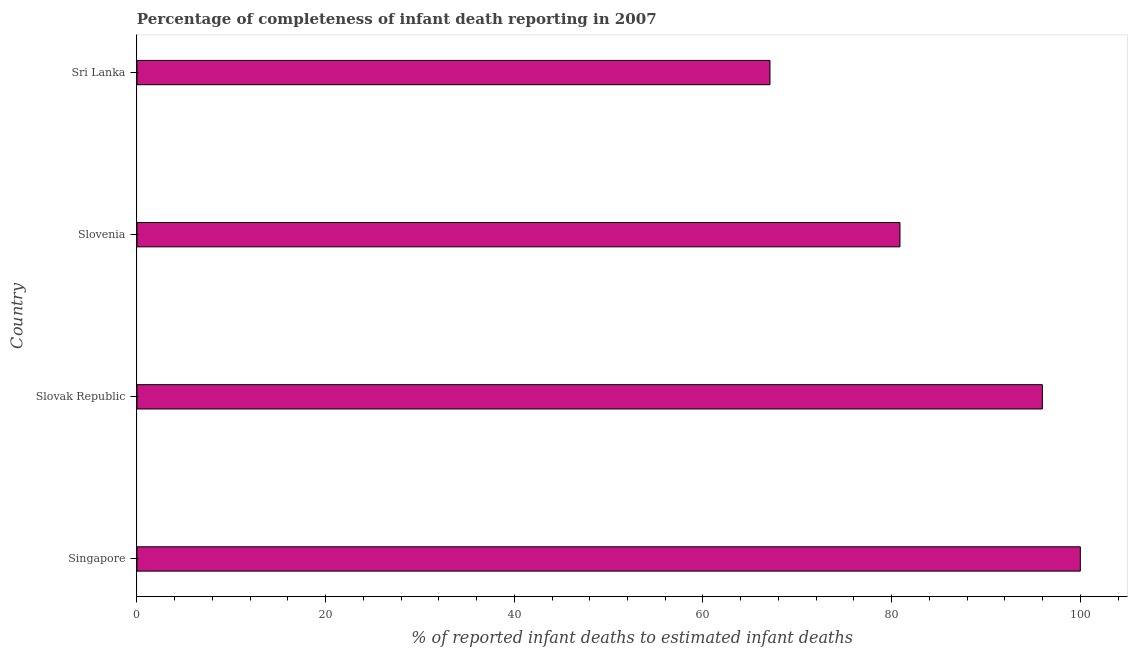Does the graph contain any zero values?
Offer a very short reply. No. Does the graph contain grids?
Give a very brief answer. No. What is the title of the graph?
Offer a very short reply. Percentage of completeness of infant death reporting in 2007. What is the label or title of the X-axis?
Your answer should be very brief. % of reported infant deaths to estimated infant deaths. Across all countries, what is the maximum completeness of infant death reporting?
Provide a short and direct response. 100. Across all countries, what is the minimum completeness of infant death reporting?
Offer a terse response. 67.1. In which country was the completeness of infant death reporting maximum?
Your response must be concise. Singapore. In which country was the completeness of infant death reporting minimum?
Offer a very short reply. Sri Lanka. What is the sum of the completeness of infant death reporting?
Provide a short and direct response. 343.96. What is the difference between the completeness of infant death reporting in Slovenia and Sri Lanka?
Your answer should be compact. 13.78. What is the average completeness of infant death reporting per country?
Give a very brief answer. 85.99. What is the median completeness of infant death reporting?
Offer a terse response. 88.43. In how many countries, is the completeness of infant death reporting greater than 52 %?
Your answer should be compact. 4. What is the ratio of the completeness of infant death reporting in Singapore to that in Sri Lanka?
Your answer should be compact. 1.49. Is the completeness of infant death reporting in Slovak Republic less than that in Sri Lanka?
Provide a succinct answer. No. What is the difference between the highest and the second highest completeness of infant death reporting?
Your answer should be compact. 4.02. What is the difference between the highest and the lowest completeness of infant death reporting?
Your answer should be compact. 32.9. Are all the bars in the graph horizontal?
Make the answer very short. Yes. How many countries are there in the graph?
Make the answer very short. 4. What is the difference between two consecutive major ticks on the X-axis?
Keep it short and to the point. 20. Are the values on the major ticks of X-axis written in scientific E-notation?
Provide a short and direct response. No. What is the % of reported infant deaths to estimated infant deaths in Slovak Republic?
Offer a very short reply. 95.98. What is the % of reported infant deaths to estimated infant deaths in Slovenia?
Provide a succinct answer. 80.88. What is the % of reported infant deaths to estimated infant deaths of Sri Lanka?
Your answer should be compact. 67.1. What is the difference between the % of reported infant deaths to estimated infant deaths in Singapore and Slovak Republic?
Keep it short and to the point. 4.02. What is the difference between the % of reported infant deaths to estimated infant deaths in Singapore and Slovenia?
Provide a succinct answer. 19.12. What is the difference between the % of reported infant deaths to estimated infant deaths in Singapore and Sri Lanka?
Provide a short and direct response. 32.9. What is the difference between the % of reported infant deaths to estimated infant deaths in Slovak Republic and Slovenia?
Your response must be concise. 15.09. What is the difference between the % of reported infant deaths to estimated infant deaths in Slovak Republic and Sri Lanka?
Your answer should be compact. 28.88. What is the difference between the % of reported infant deaths to estimated infant deaths in Slovenia and Sri Lanka?
Make the answer very short. 13.78. What is the ratio of the % of reported infant deaths to estimated infant deaths in Singapore to that in Slovak Republic?
Your response must be concise. 1.04. What is the ratio of the % of reported infant deaths to estimated infant deaths in Singapore to that in Slovenia?
Offer a very short reply. 1.24. What is the ratio of the % of reported infant deaths to estimated infant deaths in Singapore to that in Sri Lanka?
Keep it short and to the point. 1.49. What is the ratio of the % of reported infant deaths to estimated infant deaths in Slovak Republic to that in Slovenia?
Keep it short and to the point. 1.19. What is the ratio of the % of reported infant deaths to estimated infant deaths in Slovak Republic to that in Sri Lanka?
Keep it short and to the point. 1.43. What is the ratio of the % of reported infant deaths to estimated infant deaths in Slovenia to that in Sri Lanka?
Your response must be concise. 1.21. 